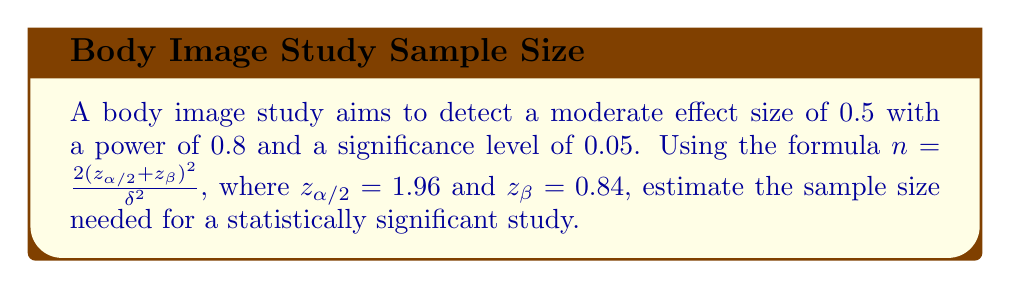What is the answer to this math problem? To estimate the sample size, we'll use the given formula and values:

1) Formula: $n = \frac{2(z_{\alpha/2} + z_{\beta})^2}{\delta^2}$

2) Given values:
   $z_{\alpha/2} = 1.96$ (for 5% significance level)
   $z_{\beta} = 0.84$ (for 80% power)
   $\delta = 0.5$ (moderate effect size)

3) Substitute the values into the formula:
   $n = \frac{2(1.96 + 0.84)^2}{(0.5)^2}$

4) Simplify the numerator:
   $n = \frac{2(2.8)^2}{(0.5)^2} = \frac{2(7.84)}{0.25}$

5) Perform the division:
   $n = \frac{15.68}{0.25} = 62.72$

6) Round up to the nearest whole number:
   $n = 63$

Therefore, a sample size of 63 participants is needed for a statistically significant body image study with the given parameters.
Answer: 63 participants 